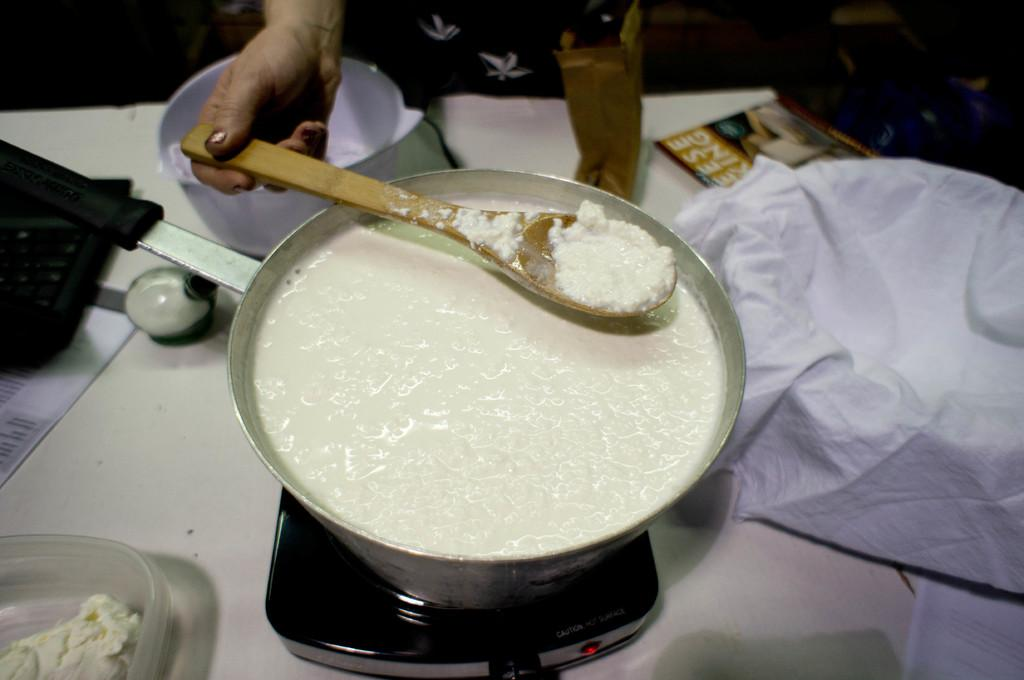Provide a one-sentence caption for the provided image. The picture looks like someone making cheese as the magazine on the table have partial words , eese, king.visible on the cover. 